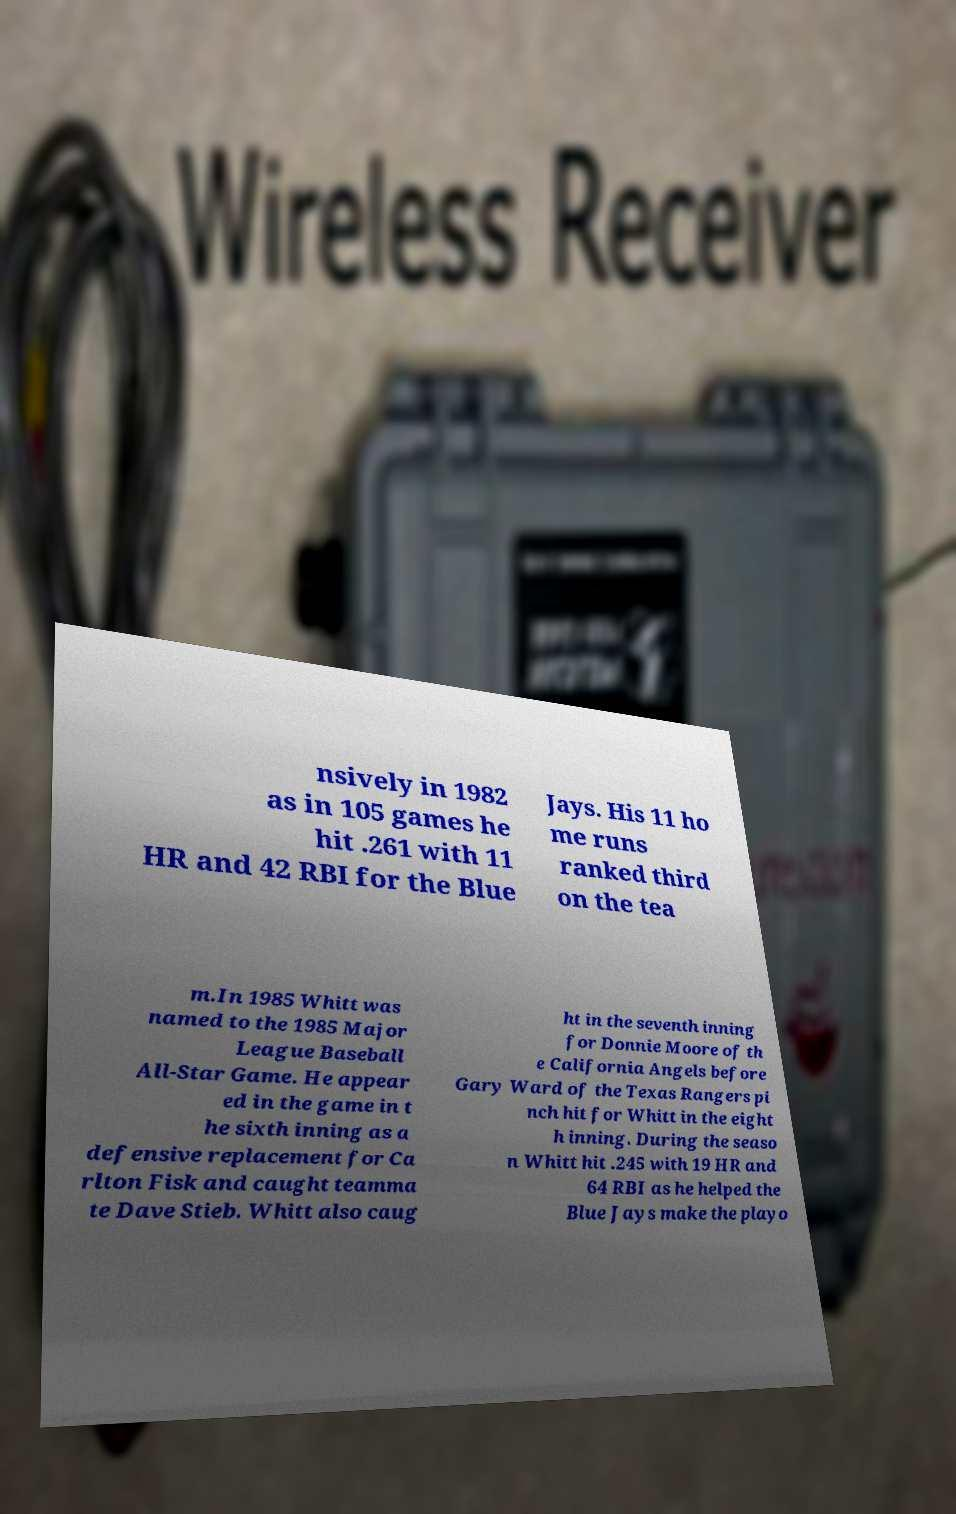What messages or text are displayed in this image? I need them in a readable, typed format. nsively in 1982 as in 105 games he hit .261 with 11 HR and 42 RBI for the Blue Jays. His 11 ho me runs ranked third on the tea m.In 1985 Whitt was named to the 1985 Major League Baseball All-Star Game. He appear ed in the game in t he sixth inning as a defensive replacement for Ca rlton Fisk and caught teamma te Dave Stieb. Whitt also caug ht in the seventh inning for Donnie Moore of th e California Angels before Gary Ward of the Texas Rangers pi nch hit for Whitt in the eight h inning. During the seaso n Whitt hit .245 with 19 HR and 64 RBI as he helped the Blue Jays make the playo 